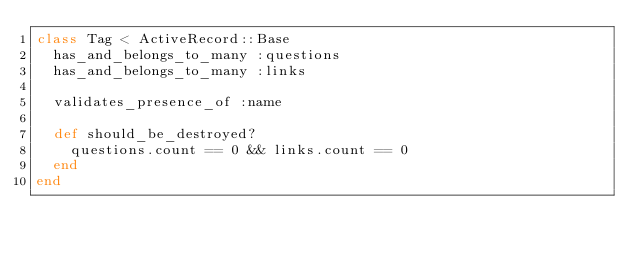Convert code to text. <code><loc_0><loc_0><loc_500><loc_500><_Ruby_>class Tag < ActiveRecord::Base
  has_and_belongs_to_many :questions
  has_and_belongs_to_many :links

  validates_presence_of :name

  def should_be_destroyed?
    questions.count == 0 && links.count == 0
  end
end
</code> 